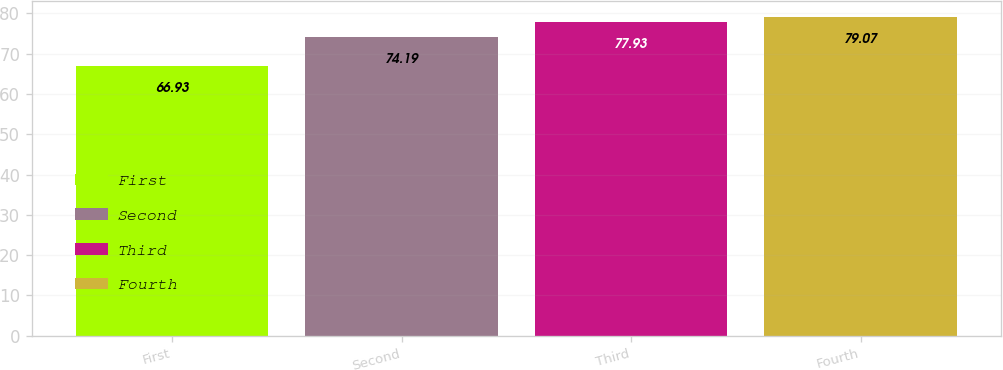Convert chart to OTSL. <chart><loc_0><loc_0><loc_500><loc_500><bar_chart><fcel>First<fcel>Second<fcel>Third<fcel>Fourth<nl><fcel>66.93<fcel>74.19<fcel>77.93<fcel>79.07<nl></chart> 